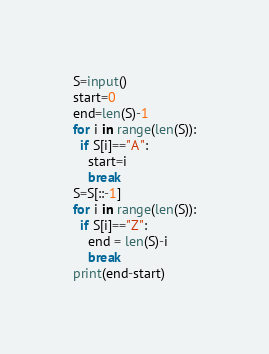Convert code to text. <code><loc_0><loc_0><loc_500><loc_500><_Python_>S=input()
start=0
end=len(S)-1
for i in range(len(S)):
  if S[i]=="A":
    start=i
    break
S=S[::-1]
for i in range(len(S)):
  if S[i]=="Z":
    end = len(S)-i
    break
print(end-start)</code> 